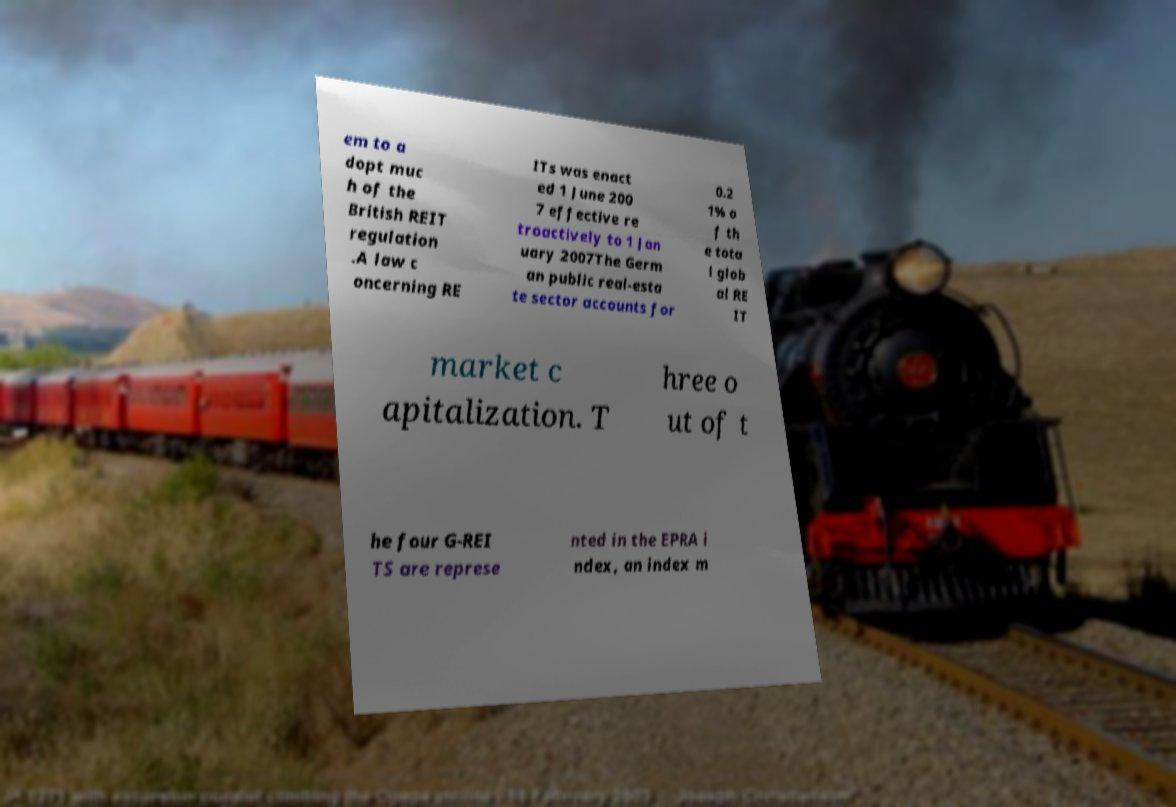Please read and relay the text visible in this image. What does it say? em to a dopt muc h of the British REIT regulation .A law c oncerning RE ITs was enact ed 1 June 200 7 effective re troactively to 1 Jan uary 2007The Germ an public real-esta te sector accounts for 0.2 1% o f th e tota l glob al RE IT market c apitalization. T hree o ut of t he four G-REI TS are represe nted in the EPRA i ndex, an index m 